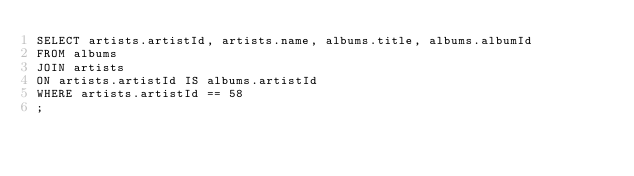<code> <loc_0><loc_0><loc_500><loc_500><_SQL_>SELECT artists.artistId, artists.name, albums.title, albums.albumId
FROM albums
JOIN artists
ON artists.artistId IS albums.artistId
WHERE artists.artistId == 58
;</code> 